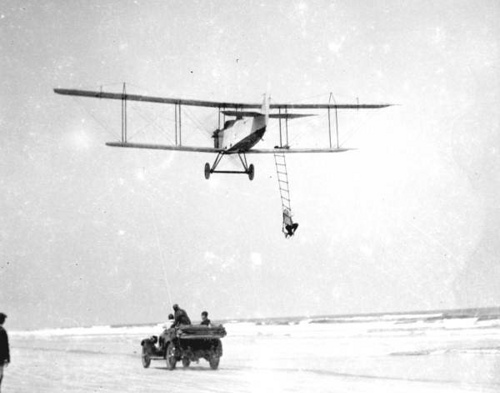<image>What time was the picture taken? I don't know what time the picture was taken. It is ambiguous. What time was the picture taken? I don't know what time the picture was taken. It can be either daytime or nighttime. 